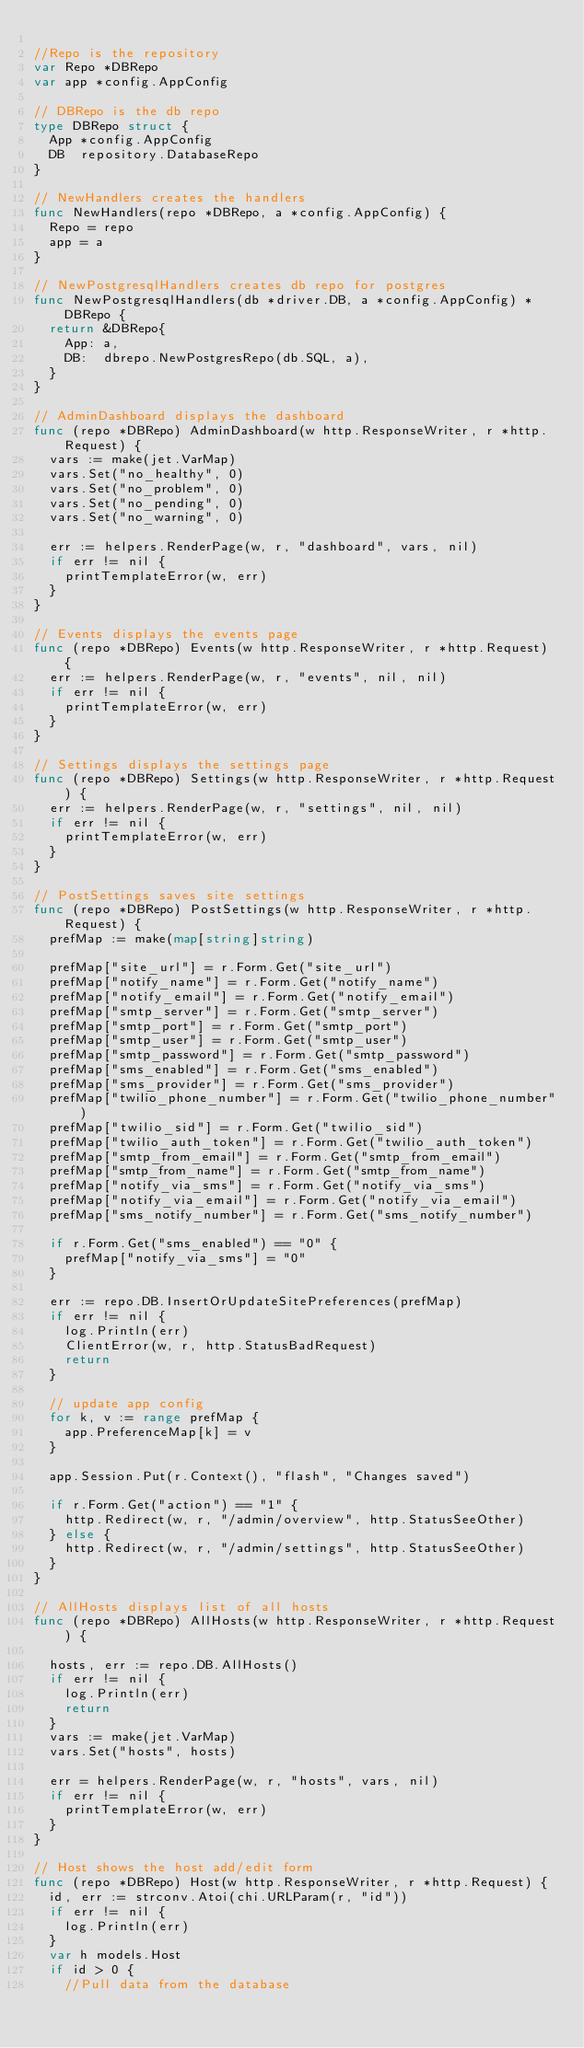Convert code to text. <code><loc_0><loc_0><loc_500><loc_500><_Go_>
//Repo is the repository
var Repo *DBRepo
var app *config.AppConfig

// DBRepo is the db repo
type DBRepo struct {
	App *config.AppConfig
	DB  repository.DatabaseRepo
}

// NewHandlers creates the handlers
func NewHandlers(repo *DBRepo, a *config.AppConfig) {
	Repo = repo
	app = a
}

// NewPostgresqlHandlers creates db repo for postgres
func NewPostgresqlHandlers(db *driver.DB, a *config.AppConfig) *DBRepo {
	return &DBRepo{
		App: a,
		DB:  dbrepo.NewPostgresRepo(db.SQL, a),
	}
}

// AdminDashboard displays the dashboard
func (repo *DBRepo) AdminDashboard(w http.ResponseWriter, r *http.Request) {
	vars := make(jet.VarMap)
	vars.Set("no_healthy", 0)
	vars.Set("no_problem", 0)
	vars.Set("no_pending", 0)
	vars.Set("no_warning", 0)

	err := helpers.RenderPage(w, r, "dashboard", vars, nil)
	if err != nil {
		printTemplateError(w, err)
	}
}

// Events displays the events page
func (repo *DBRepo) Events(w http.ResponseWriter, r *http.Request) {
	err := helpers.RenderPage(w, r, "events", nil, nil)
	if err != nil {
		printTemplateError(w, err)
	}
}

// Settings displays the settings page
func (repo *DBRepo) Settings(w http.ResponseWriter, r *http.Request) {
	err := helpers.RenderPage(w, r, "settings", nil, nil)
	if err != nil {
		printTemplateError(w, err)
	}
}

// PostSettings saves site settings
func (repo *DBRepo) PostSettings(w http.ResponseWriter, r *http.Request) {
	prefMap := make(map[string]string)

	prefMap["site_url"] = r.Form.Get("site_url")
	prefMap["notify_name"] = r.Form.Get("notify_name")
	prefMap["notify_email"] = r.Form.Get("notify_email")
	prefMap["smtp_server"] = r.Form.Get("smtp_server")
	prefMap["smtp_port"] = r.Form.Get("smtp_port")
	prefMap["smtp_user"] = r.Form.Get("smtp_user")
	prefMap["smtp_password"] = r.Form.Get("smtp_password")
	prefMap["sms_enabled"] = r.Form.Get("sms_enabled")
	prefMap["sms_provider"] = r.Form.Get("sms_provider")
	prefMap["twilio_phone_number"] = r.Form.Get("twilio_phone_number")
	prefMap["twilio_sid"] = r.Form.Get("twilio_sid")
	prefMap["twilio_auth_token"] = r.Form.Get("twilio_auth_token")
	prefMap["smtp_from_email"] = r.Form.Get("smtp_from_email")
	prefMap["smtp_from_name"] = r.Form.Get("smtp_from_name")
	prefMap["notify_via_sms"] = r.Form.Get("notify_via_sms")
	prefMap["notify_via_email"] = r.Form.Get("notify_via_email")
	prefMap["sms_notify_number"] = r.Form.Get("sms_notify_number")

	if r.Form.Get("sms_enabled") == "0" {
		prefMap["notify_via_sms"] = "0"
	}

	err := repo.DB.InsertOrUpdateSitePreferences(prefMap)
	if err != nil {
		log.Println(err)
		ClientError(w, r, http.StatusBadRequest)
		return
	}

	// update app config
	for k, v := range prefMap {
		app.PreferenceMap[k] = v
	}

	app.Session.Put(r.Context(), "flash", "Changes saved")

	if r.Form.Get("action") == "1" {
		http.Redirect(w, r, "/admin/overview", http.StatusSeeOther)
	} else {
		http.Redirect(w, r, "/admin/settings", http.StatusSeeOther)
	}
}

// AllHosts displays list of all hosts
func (repo *DBRepo) AllHosts(w http.ResponseWriter, r *http.Request) {

	hosts, err := repo.DB.AllHosts()
	if err != nil {
		log.Println(err)
		return
	}
	vars := make(jet.VarMap)
	vars.Set("hosts", hosts)

	err = helpers.RenderPage(w, r, "hosts", vars, nil)
	if err != nil {
		printTemplateError(w, err)
	}
}

// Host shows the host add/edit form
func (repo *DBRepo) Host(w http.ResponseWriter, r *http.Request) {
	id, err := strconv.Atoi(chi.URLParam(r, "id"))
	if err != nil {
		log.Println(err)
	}
	var h models.Host
	if id > 0 {
		//Pull data from the database</code> 